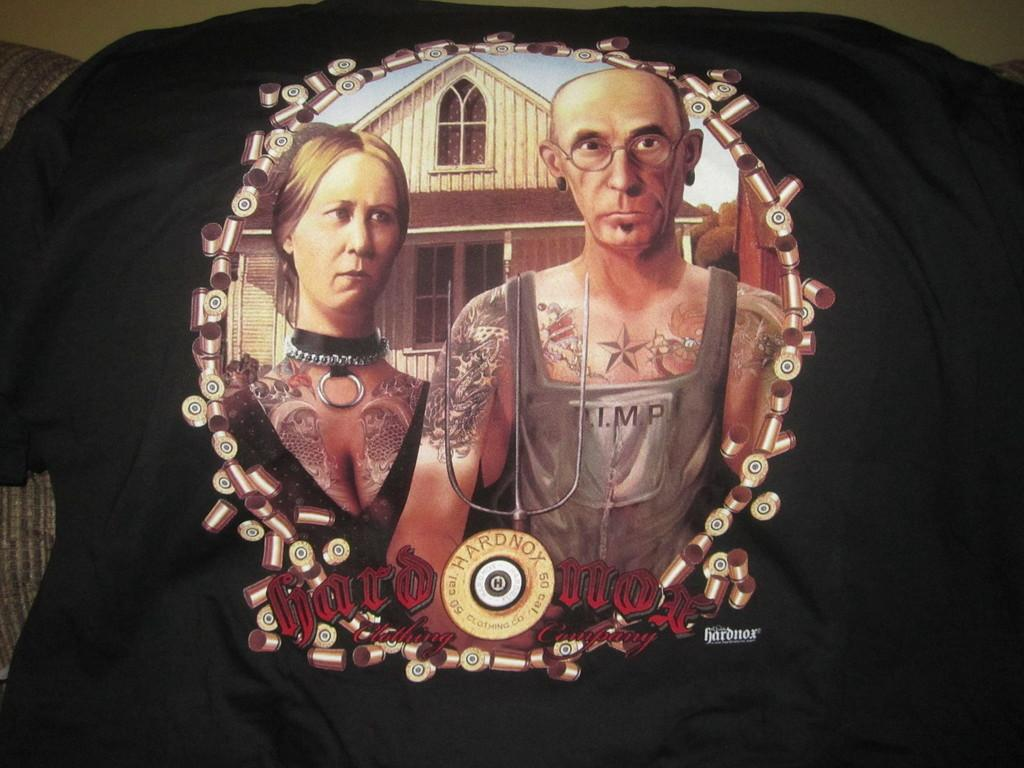How many people are depicted on the T-shirt? There are two persons in the image. What is the color of the T-shirt? The color of the T-shirt is not mentioned, but it has a black background for the image. What is written below the image on the T-shirt? There is text written below the image on the T-shirt. How many babies are shown reading books in the image? There are no babies or books present in the image; it features two persons. What type of competition is taking place in the image? There is no competition depicted in the image; it simply shows two persons. 